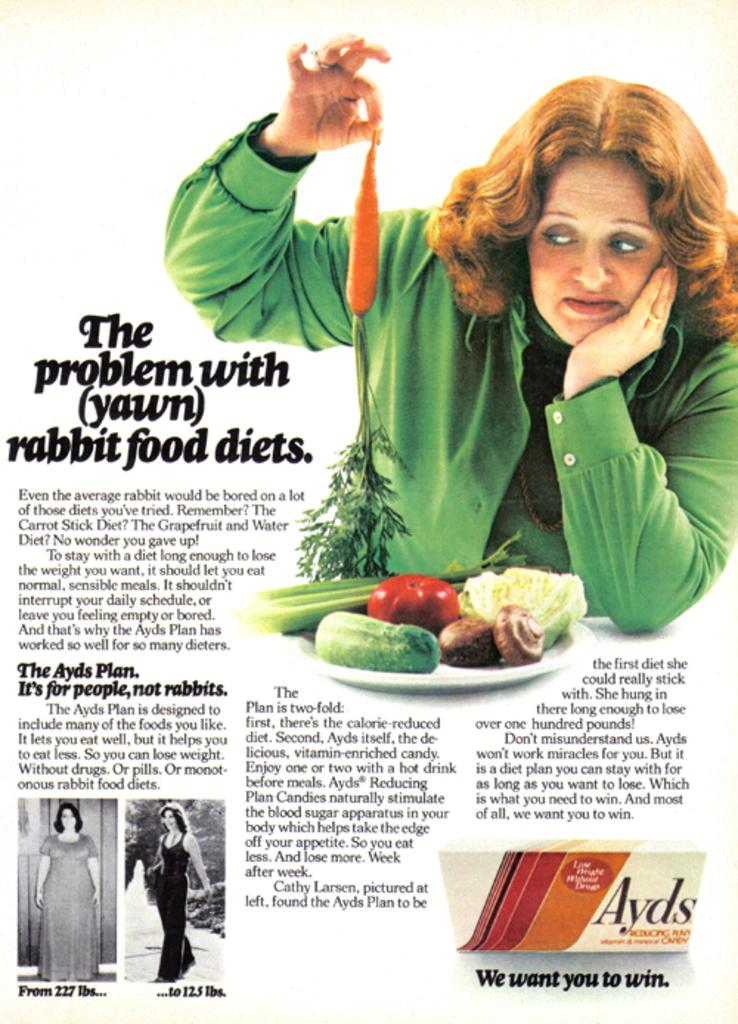<image>
Relay a brief, clear account of the picture shown. an article titled the problem with rabbit food diets 